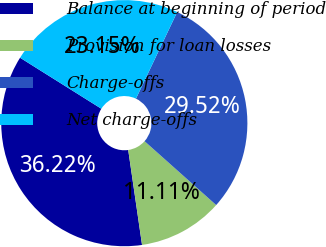Convert chart to OTSL. <chart><loc_0><loc_0><loc_500><loc_500><pie_chart><fcel>Balance at beginning of period<fcel>Provision for loan losses<fcel>Charge-offs<fcel>Net charge-offs<nl><fcel>36.22%<fcel>11.11%<fcel>29.52%<fcel>23.15%<nl></chart> 